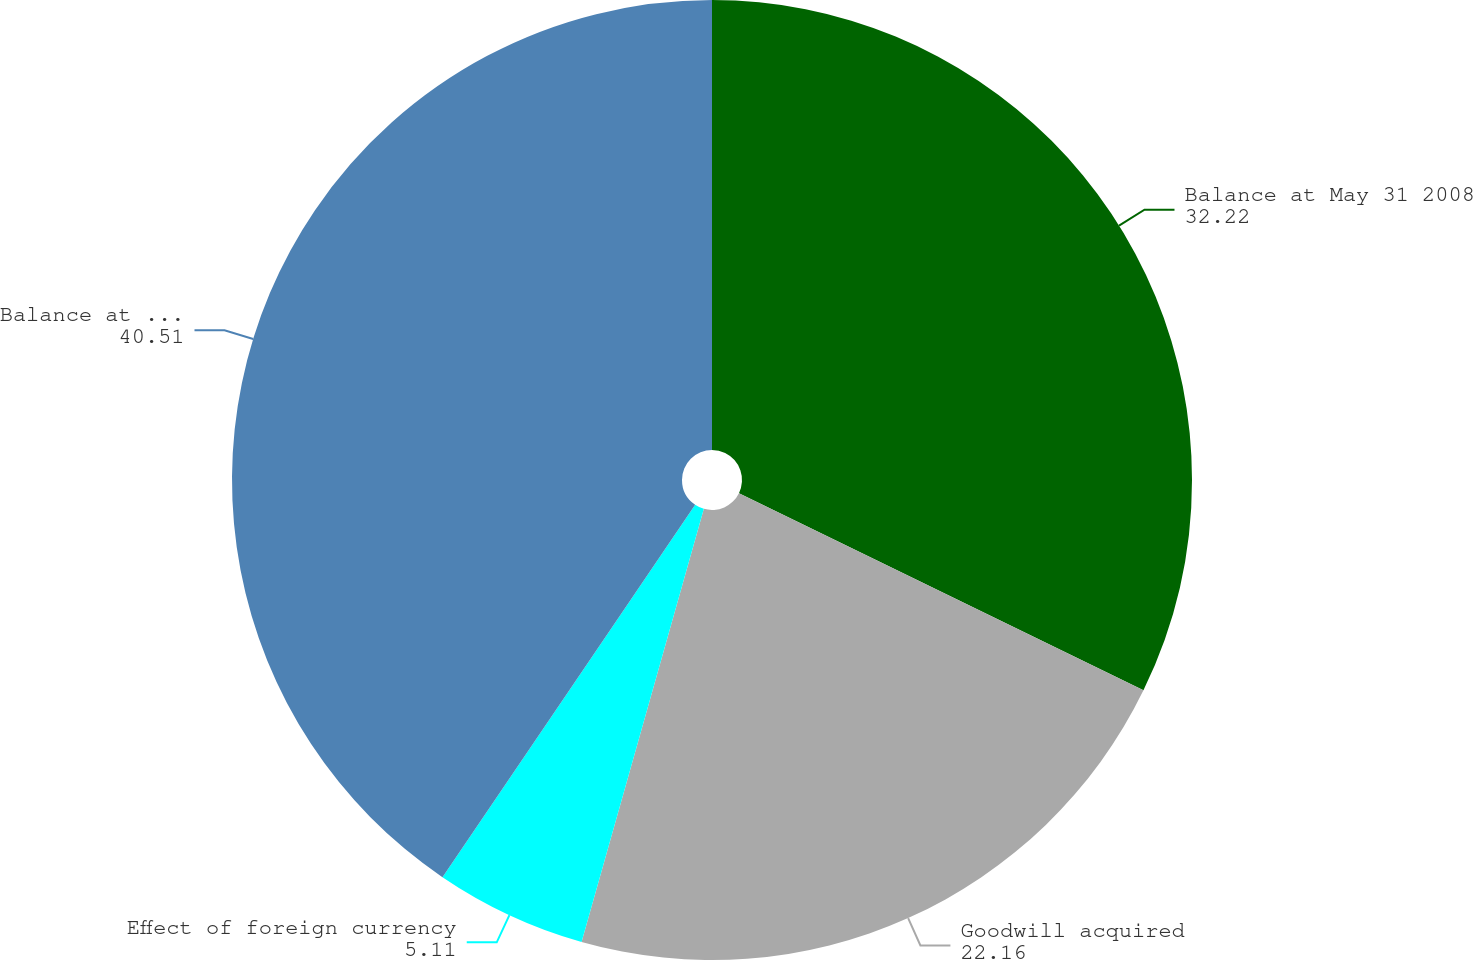Convert chart. <chart><loc_0><loc_0><loc_500><loc_500><pie_chart><fcel>Balance at May 31 2008<fcel>Goodwill acquired<fcel>Effect of foreign currency<fcel>Balance at May 31 2009<nl><fcel>32.22%<fcel>22.16%<fcel>5.11%<fcel>40.51%<nl></chart> 